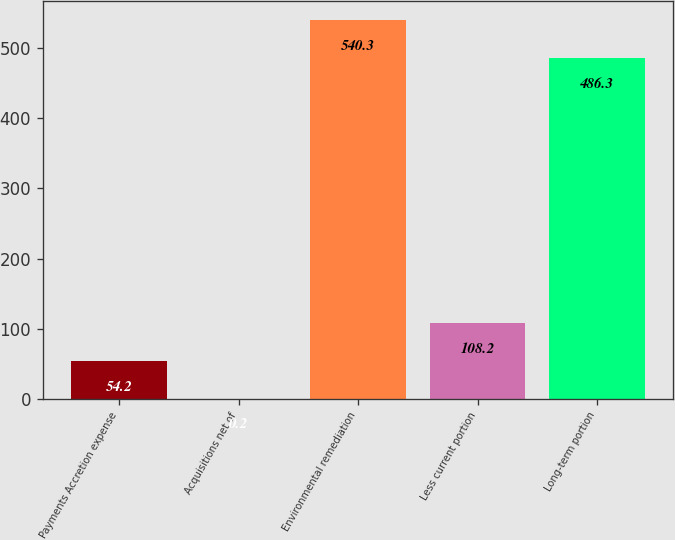Convert chart. <chart><loc_0><loc_0><loc_500><loc_500><bar_chart><fcel>Payments Accretion expense<fcel>Acquisitions net of<fcel>Environmental remediation<fcel>Less current portion<fcel>Long-term portion<nl><fcel>54.2<fcel>0.2<fcel>540.3<fcel>108.2<fcel>486.3<nl></chart> 